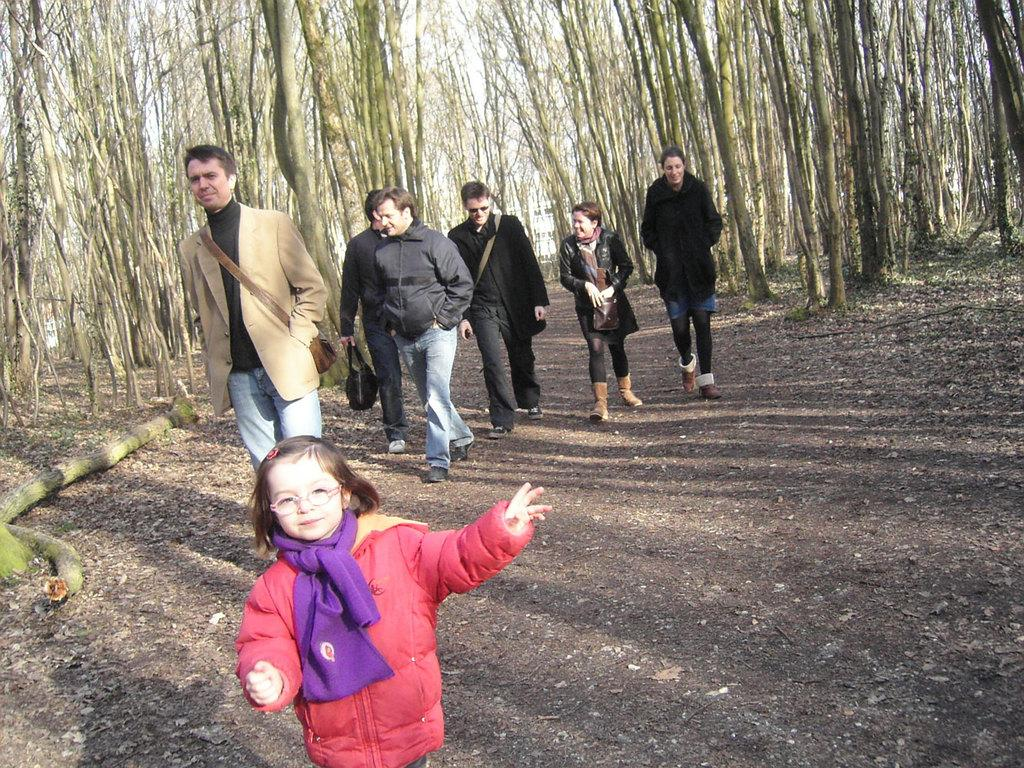What is the main subject of the image? There is a child in the image. What are the people in the image doing? The people are walking on a path in the image. Can you describe the actions of one of the individuals? One person is holding a bag in their hand. What can be seen in the background of the image? There are tree trunks in the background of the image. How many beams are supporting the child in the image? There are no beams present in the image; the child is not being supported by any structures. 